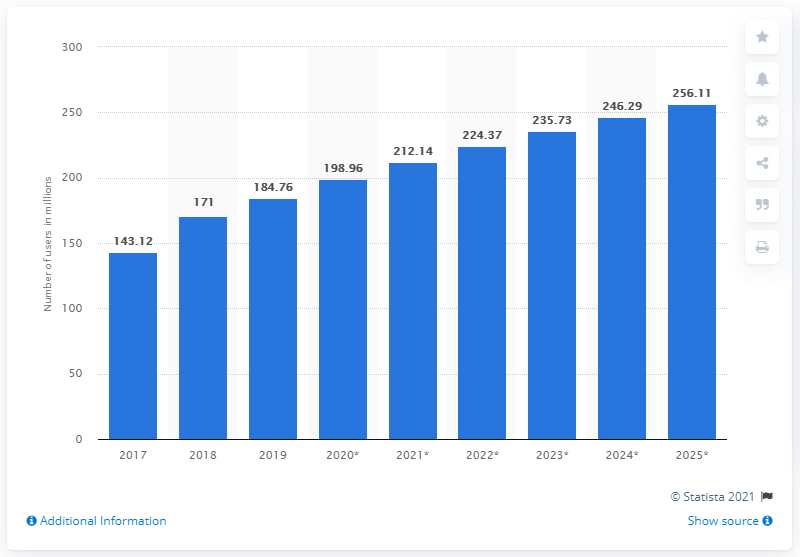Mention a couple of crucial points in this snapshot. By 2025, it is estimated that there will be approximately 256.11 million social network users in Indonesia. In 2019, there were 184.76 million social network users in Indonesia. 